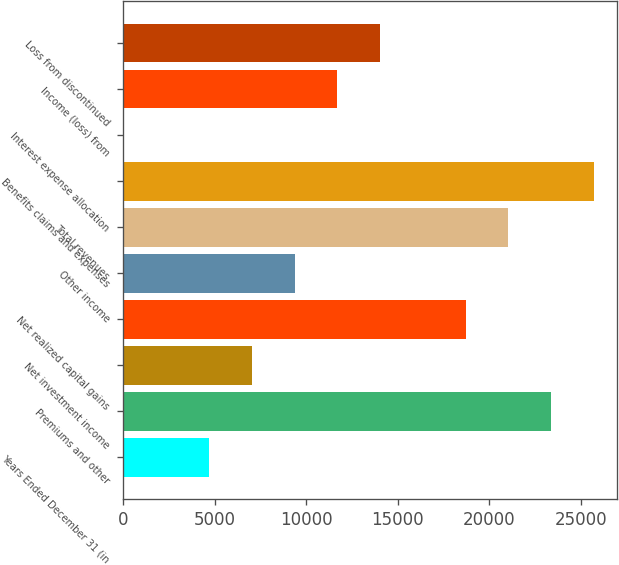<chart> <loc_0><loc_0><loc_500><loc_500><bar_chart><fcel>Years Ended December 31 (in<fcel>Premiums and other<fcel>Net investment income<fcel>Net realized capital gains<fcel>Other income<fcel>Total revenues<fcel>Benefits claims and expenses<fcel>Interest expense allocation<fcel>Income (loss) from<fcel>Loss from discontinued<nl><fcel>4715.2<fcel>23356<fcel>7045.3<fcel>18695.8<fcel>9375.4<fcel>21025.9<fcel>25686.1<fcel>55<fcel>11705.5<fcel>14035.6<nl></chart> 